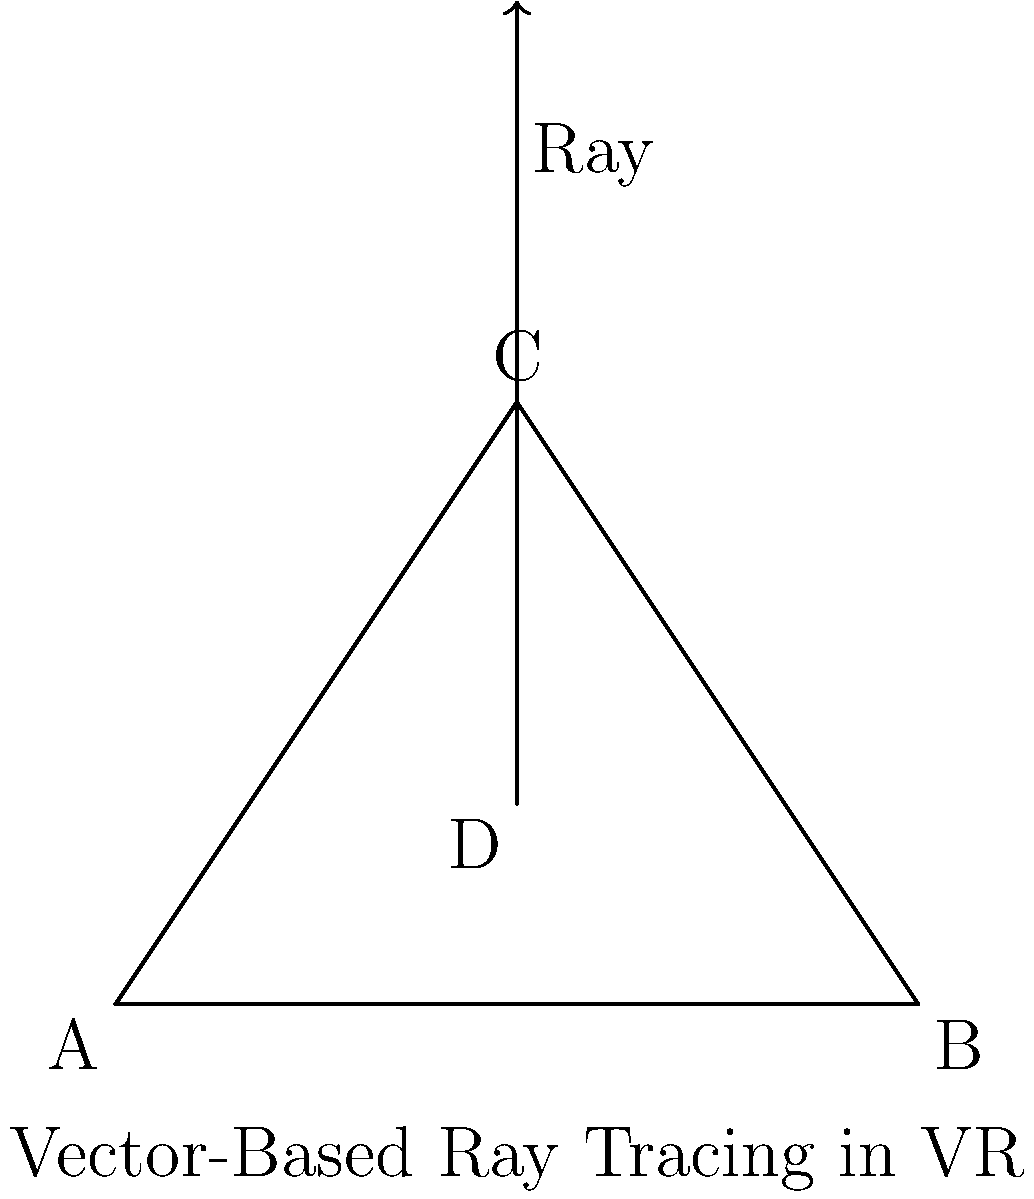In the context of vector-based ray tracing for VR educational applications, how does increasing the number of rays cast from point D affect the rendering quality and computational performance of the virtual environment? To understand the impact of increasing the number of rays in vector-based ray tracing for VR educational applications, let's break down the process:

1. Ray tracing basics:
   - Ray tracing simulates the path of light rays to create realistic images.
   - In VR, this technique is used to render immersive 3D environments.

2. Vector-based approach:
   - Rays are represented as vectors, originating from a point (e.g., point D in the diagram).
   - Each ray is defined by its origin and direction vector.

3. Impact on rendering quality:
   - More rays allow for better sampling of the environment.
   - This leads to improved accuracy in lighting, shadows, and reflections.
   - Finer details and smoother transitions between surfaces can be captured.

4. Effect on computational performance:
   - Each ray requires calculations for intersections with objects in the scene.
   - More rays mean more calculations, increasing computational load.
   - This can lead to longer rendering times or reduced frame rates.

5. Trade-off considerations:
   - VR applications require high frame rates (typically 90 fps or higher) for comfort.
   - Balancing quality and performance is crucial for educational VR applications.

6. Optimization techniques:
   - Adaptive ray tracing: casting more rays in complex areas of the scene.
   - Using acceleration structures (e.g., bounding volume hierarchies) to speed up intersection tests.
   - Implementing parallel processing on GPUs to handle increased ray counts.

7. Educational application considerations:
   - Higher quality rendering can enhance immersion and learning experiences.
   - Performance issues can lead to discomfort or reduced engagement.

In conclusion, increasing the number of rays improves rendering quality but at the cost of computational performance. The optimal number of rays depends on the specific educational application, available hardware, and desired balance between visual fidelity and performance.
Answer: Improves quality, increases computational load; requires optimization for VR performance. 